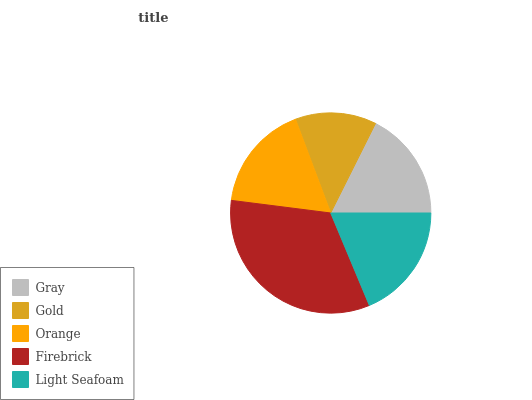Is Gold the minimum?
Answer yes or no. Yes. Is Firebrick the maximum?
Answer yes or no. Yes. Is Orange the minimum?
Answer yes or no. No. Is Orange the maximum?
Answer yes or no. No. Is Orange greater than Gold?
Answer yes or no. Yes. Is Gold less than Orange?
Answer yes or no. Yes. Is Gold greater than Orange?
Answer yes or no. No. Is Orange less than Gold?
Answer yes or no. No. Is Gray the high median?
Answer yes or no. Yes. Is Gray the low median?
Answer yes or no. Yes. Is Orange the high median?
Answer yes or no. No. Is Firebrick the low median?
Answer yes or no. No. 